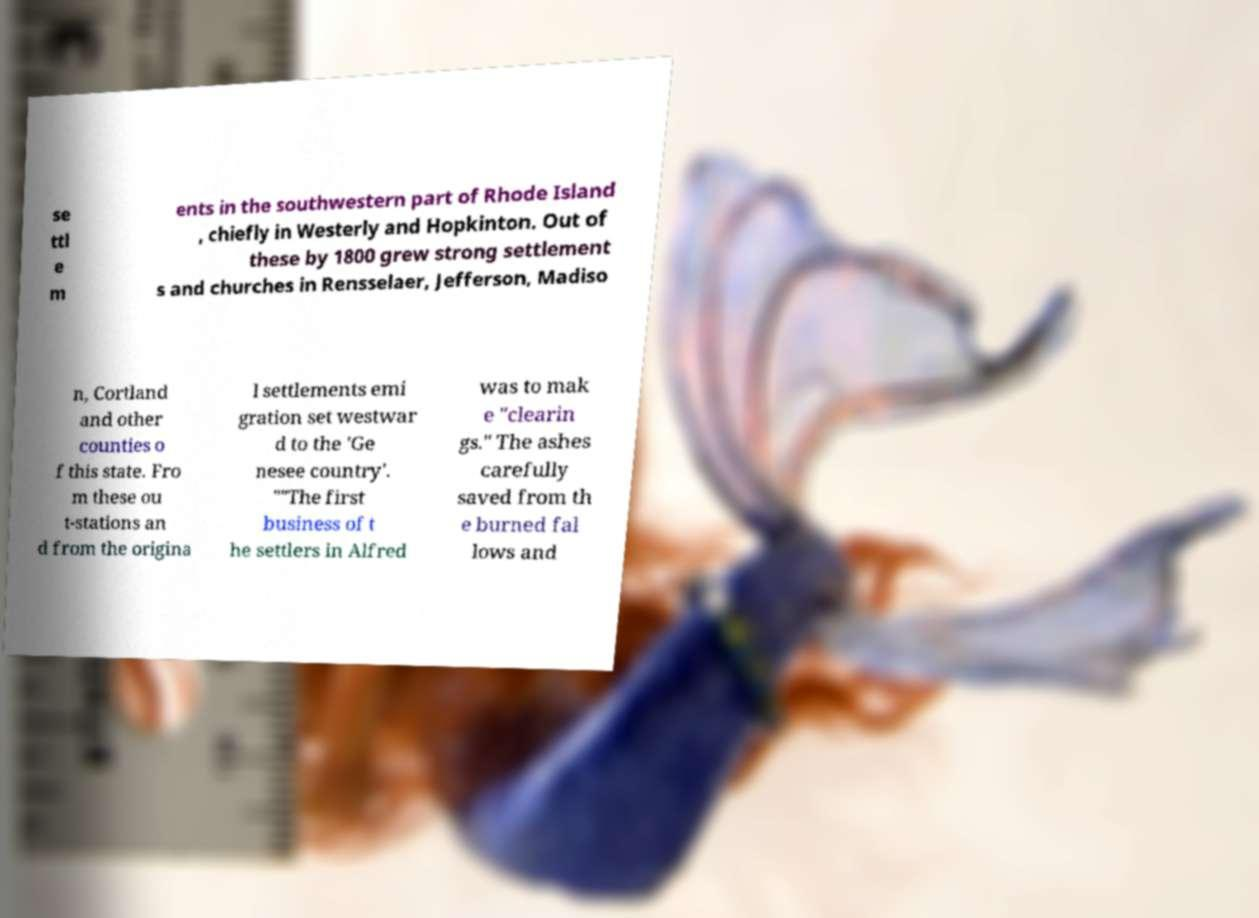Could you assist in decoding the text presented in this image and type it out clearly? se ttl e m ents in the southwestern part of Rhode Island , chiefly in Westerly and Hopkinton. Out of these by 1800 grew strong settlement s and churches in Rensselaer, Jefferson, Madiso n, Cortland and other counties o f this state. Fro m these ou t-stations an d from the origina l settlements emi gration set westwar d to the 'Ge nesee country'. ""The first business of t he settlers in Alfred was to mak e "clearin gs." The ashes carefully saved from th e burned fal lows and 